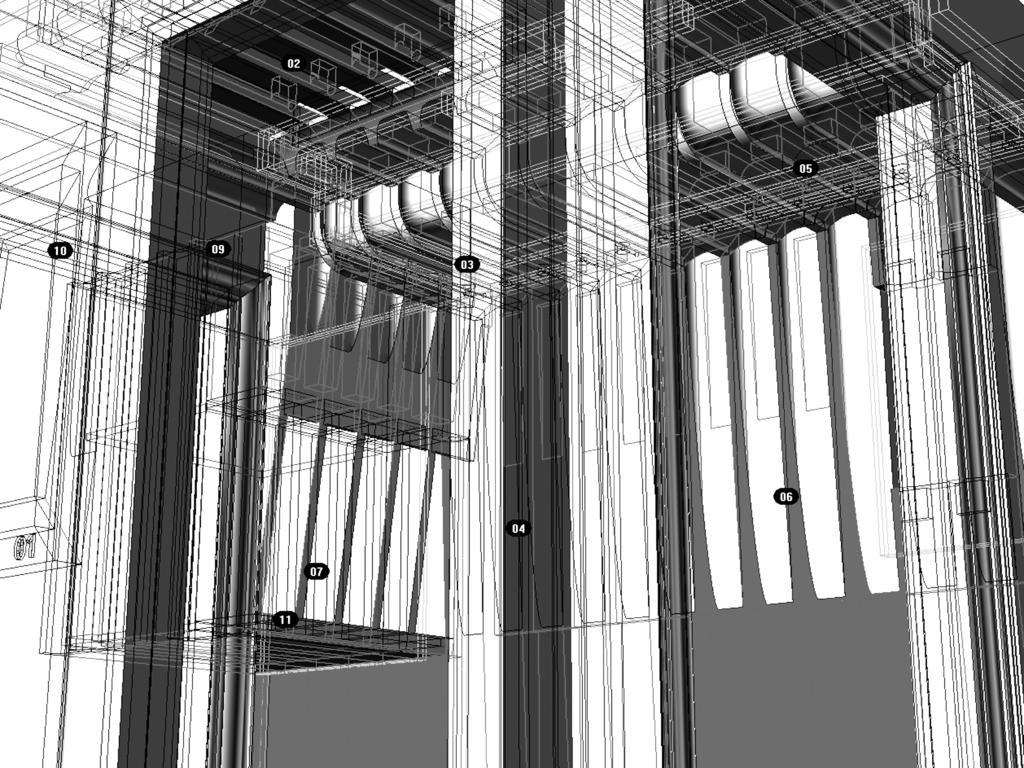What is the color scheme of the image? The image is black and white. What is the main subject of the image? The image depicts an architectural design of a building. How is the building design presented in the image? The building design appears to be a digital art. How many pigs are present in the image? There are no pigs present in the image; it features an architectural design of a building. What type of event is taking place in the image? There is no event depicted in the image; it is a black and white digital art of a building design. 